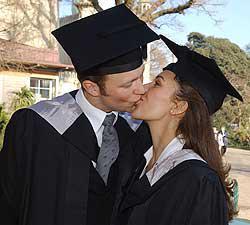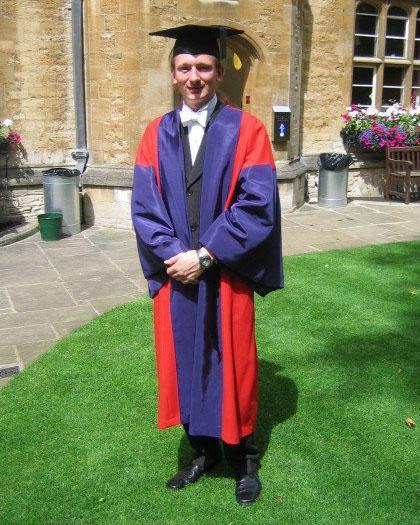The first image is the image on the left, the second image is the image on the right. Assess this claim about the two images: "Two college graduates wearing black gowns and mortarboards are the focus of one image, while a single male wearing a gown is the focus of the second image.". Correct or not? Answer yes or no. Yes. The first image is the image on the left, the second image is the image on the right. Examine the images to the left and right. Is the description "A single graduate is posing wearing a blue outfit in the image on the right." accurate? Answer yes or no. Yes. 